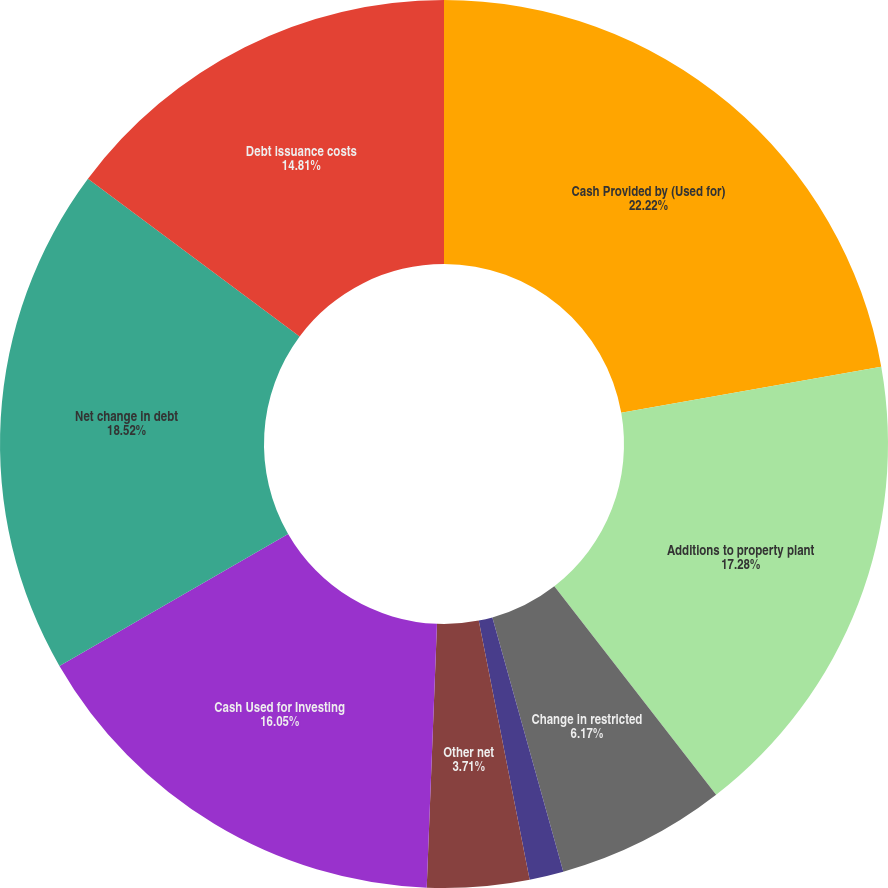Convert chart. <chart><loc_0><loc_0><loc_500><loc_500><pie_chart><fcel>Cash Provided by (Used for)<fcel>Additions to property plant<fcel>Change in restricted<fcel>Proceeds from sale of<fcel>Acquisitions net of cash<fcel>Other net<fcel>Cash Used for Investing<fcel>Net change in debt<fcel>Debt issuance costs<nl><fcel>22.22%<fcel>17.28%<fcel>6.17%<fcel>0.0%<fcel>1.24%<fcel>3.71%<fcel>16.05%<fcel>18.52%<fcel>14.81%<nl></chart> 